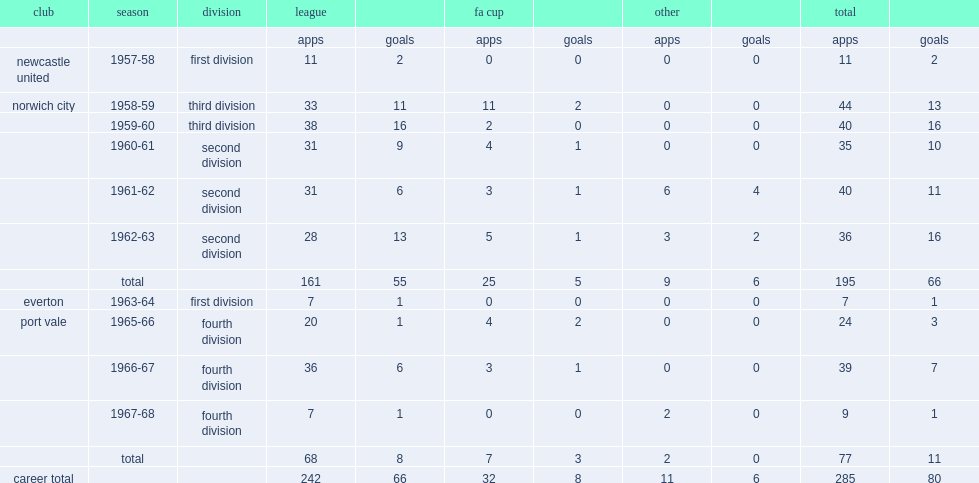In 1959-60, how many goals did hill score for norwich city in the third division? 16.0. Can you give me this table as a dict? {'header': ['club', 'season', 'division', 'league', '', 'fa cup', '', 'other', '', 'total', ''], 'rows': [['', '', '', 'apps', 'goals', 'apps', 'goals', 'apps', 'goals', 'apps', 'goals'], ['newcastle united', '1957-58', 'first division', '11', '2', '0', '0', '0', '0', '11', '2'], ['norwich city', '1958-59', 'third division', '33', '11', '11', '2', '0', '0', '44', '13'], ['', '1959-60', 'third division', '38', '16', '2', '0', '0', '0', '40', '16'], ['', '1960-61', 'second division', '31', '9', '4', '1', '0', '0', '35', '10'], ['', '1961-62', 'second division', '31', '6', '3', '1', '6', '4', '40', '11'], ['', '1962-63', 'second division', '28', '13', '5', '1', '3', '2', '36', '16'], ['', 'total', '', '161', '55', '25', '5', '9', '6', '195', '66'], ['everton', '1963-64', 'first division', '7', '1', '0', '0', '0', '0', '7', '1'], ['port vale', '1965-66', 'fourth division', '20', '1', '4', '2', '0', '0', '24', '3'], ['', '1966-67', 'fourth division', '36', '6', '3', '1', '0', '0', '39', '7'], ['', '1967-68', 'fourth division', '7', '1', '0', '0', '2', '0', '9', '1'], ['', 'total', '', '68', '8', '7', '3', '2', '0', '77', '11'], ['career total', '', '', '242', '66', '32', '8', '11', '6', '285', '80']]} 